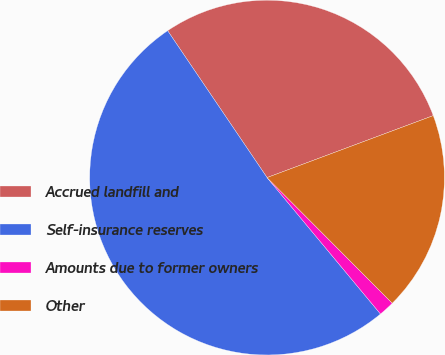Convert chart. <chart><loc_0><loc_0><loc_500><loc_500><pie_chart><fcel>Accrued landfill and<fcel>Self-insurance reserves<fcel>Amounts due to former owners<fcel>Other<nl><fcel>28.79%<fcel>51.57%<fcel>1.43%<fcel>18.21%<nl></chart> 